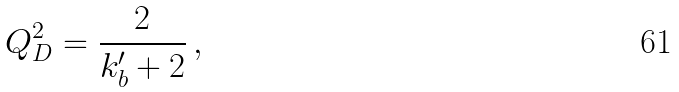Convert formula to latex. <formula><loc_0><loc_0><loc_500><loc_500>Q _ { D } ^ { 2 } = \frac { 2 } { k _ { b } ^ { \prime } + 2 } \, ,</formula> 